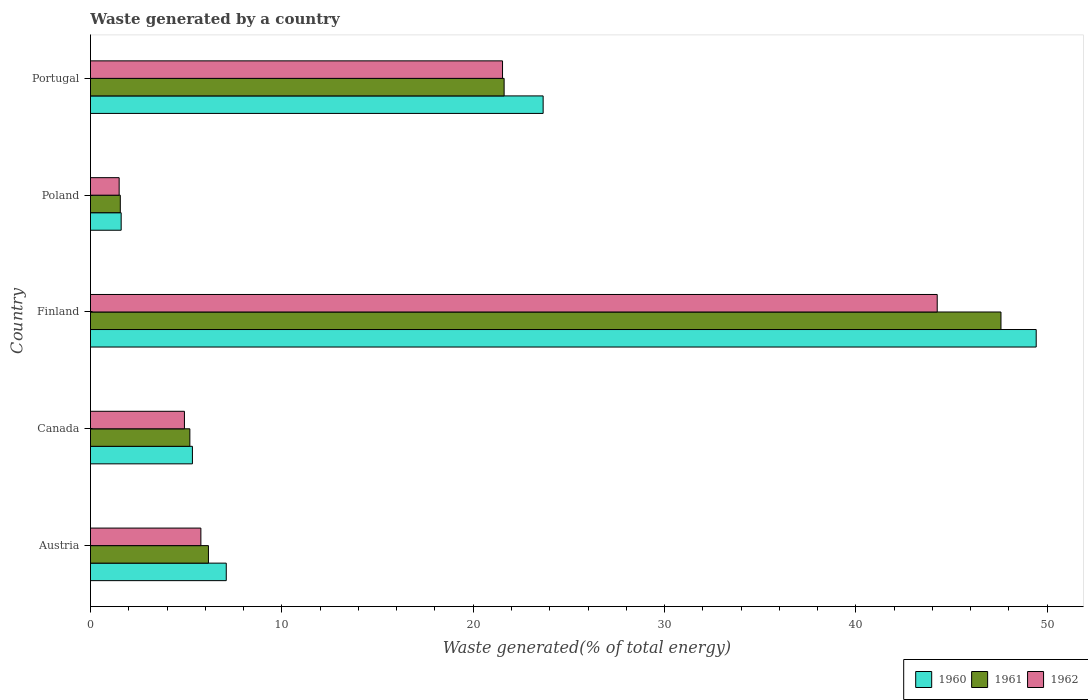How many different coloured bars are there?
Offer a very short reply. 3. How many groups of bars are there?
Give a very brief answer. 5. Are the number of bars per tick equal to the number of legend labels?
Give a very brief answer. Yes. Are the number of bars on each tick of the Y-axis equal?
Give a very brief answer. Yes. How many bars are there on the 3rd tick from the top?
Your response must be concise. 3. How many bars are there on the 5th tick from the bottom?
Provide a succinct answer. 3. What is the label of the 1st group of bars from the top?
Provide a short and direct response. Portugal. What is the total waste generated in 1962 in Poland?
Provide a succinct answer. 1.5. Across all countries, what is the maximum total waste generated in 1962?
Keep it short and to the point. 44.25. Across all countries, what is the minimum total waste generated in 1962?
Keep it short and to the point. 1.5. In which country was the total waste generated in 1960 maximum?
Your answer should be compact. Finland. What is the total total waste generated in 1961 in the graph?
Ensure brevity in your answer.  82.12. What is the difference between the total waste generated in 1962 in Finland and that in Portugal?
Offer a terse response. 22.72. What is the difference between the total waste generated in 1960 in Poland and the total waste generated in 1962 in Canada?
Provide a short and direct response. -3.31. What is the average total waste generated in 1962 per country?
Offer a very short reply. 15.59. What is the difference between the total waste generated in 1962 and total waste generated in 1960 in Portugal?
Provide a succinct answer. -2.12. In how many countries, is the total waste generated in 1962 greater than 22 %?
Provide a succinct answer. 1. What is the ratio of the total waste generated in 1961 in Canada to that in Finland?
Ensure brevity in your answer.  0.11. Is the difference between the total waste generated in 1962 in Canada and Poland greater than the difference between the total waste generated in 1960 in Canada and Poland?
Your answer should be compact. No. What is the difference between the highest and the second highest total waste generated in 1961?
Provide a short and direct response. 25.96. What is the difference between the highest and the lowest total waste generated in 1960?
Your response must be concise. 47.82. What does the 1st bar from the bottom in Poland represents?
Offer a very short reply. 1960. Is it the case that in every country, the sum of the total waste generated in 1960 and total waste generated in 1962 is greater than the total waste generated in 1961?
Your answer should be very brief. Yes. How many bars are there?
Provide a succinct answer. 15. How many countries are there in the graph?
Your answer should be very brief. 5. What is the difference between two consecutive major ticks on the X-axis?
Ensure brevity in your answer.  10. Does the graph contain any zero values?
Ensure brevity in your answer.  No. Where does the legend appear in the graph?
Your answer should be compact. Bottom right. How are the legend labels stacked?
Your response must be concise. Horizontal. What is the title of the graph?
Ensure brevity in your answer.  Waste generated by a country. What is the label or title of the X-axis?
Offer a terse response. Waste generated(% of total energy). What is the label or title of the Y-axis?
Offer a very short reply. Country. What is the Waste generated(% of total energy) in 1960 in Austria?
Your answer should be very brief. 7.1. What is the Waste generated(% of total energy) in 1961 in Austria?
Ensure brevity in your answer.  6.16. What is the Waste generated(% of total energy) in 1962 in Austria?
Your answer should be very brief. 5.77. What is the Waste generated(% of total energy) of 1960 in Canada?
Offer a very short reply. 5.33. What is the Waste generated(% of total energy) in 1961 in Canada?
Your response must be concise. 5.19. What is the Waste generated(% of total energy) of 1962 in Canada?
Provide a succinct answer. 4.91. What is the Waste generated(% of total energy) in 1960 in Finland?
Ensure brevity in your answer.  49.42. What is the Waste generated(% of total energy) in 1961 in Finland?
Offer a terse response. 47.58. What is the Waste generated(% of total energy) of 1962 in Finland?
Provide a short and direct response. 44.25. What is the Waste generated(% of total energy) in 1960 in Poland?
Give a very brief answer. 1.6. What is the Waste generated(% of total energy) in 1961 in Poland?
Your answer should be compact. 1.56. What is the Waste generated(% of total energy) in 1962 in Poland?
Keep it short and to the point. 1.5. What is the Waste generated(% of total energy) of 1960 in Portugal?
Give a very brief answer. 23.66. What is the Waste generated(% of total energy) in 1961 in Portugal?
Keep it short and to the point. 21.62. What is the Waste generated(% of total energy) in 1962 in Portugal?
Ensure brevity in your answer.  21.53. Across all countries, what is the maximum Waste generated(% of total energy) in 1960?
Keep it short and to the point. 49.42. Across all countries, what is the maximum Waste generated(% of total energy) of 1961?
Your answer should be very brief. 47.58. Across all countries, what is the maximum Waste generated(% of total energy) in 1962?
Your answer should be very brief. 44.25. Across all countries, what is the minimum Waste generated(% of total energy) of 1960?
Your answer should be very brief. 1.6. Across all countries, what is the minimum Waste generated(% of total energy) of 1961?
Offer a terse response. 1.56. Across all countries, what is the minimum Waste generated(% of total energy) of 1962?
Keep it short and to the point. 1.5. What is the total Waste generated(% of total energy) in 1960 in the graph?
Offer a very short reply. 87.11. What is the total Waste generated(% of total energy) in 1961 in the graph?
Give a very brief answer. 82.12. What is the total Waste generated(% of total energy) of 1962 in the graph?
Provide a succinct answer. 77.96. What is the difference between the Waste generated(% of total energy) of 1960 in Austria and that in Canada?
Your answer should be very brief. 1.77. What is the difference between the Waste generated(% of total energy) in 1961 in Austria and that in Canada?
Provide a short and direct response. 0.97. What is the difference between the Waste generated(% of total energy) in 1962 in Austria and that in Canada?
Make the answer very short. 0.86. What is the difference between the Waste generated(% of total energy) in 1960 in Austria and that in Finland?
Offer a terse response. -42.33. What is the difference between the Waste generated(% of total energy) in 1961 in Austria and that in Finland?
Offer a very short reply. -41.42. What is the difference between the Waste generated(% of total energy) in 1962 in Austria and that in Finland?
Your answer should be very brief. -38.48. What is the difference between the Waste generated(% of total energy) of 1960 in Austria and that in Poland?
Offer a terse response. 5.49. What is the difference between the Waste generated(% of total energy) in 1961 in Austria and that in Poland?
Provide a short and direct response. 4.61. What is the difference between the Waste generated(% of total energy) of 1962 in Austria and that in Poland?
Keep it short and to the point. 4.27. What is the difference between the Waste generated(% of total energy) of 1960 in Austria and that in Portugal?
Give a very brief answer. -16.56. What is the difference between the Waste generated(% of total energy) in 1961 in Austria and that in Portugal?
Your answer should be compact. -15.45. What is the difference between the Waste generated(% of total energy) in 1962 in Austria and that in Portugal?
Your answer should be compact. -15.76. What is the difference between the Waste generated(% of total energy) in 1960 in Canada and that in Finland?
Make the answer very short. -44.1. What is the difference between the Waste generated(% of total energy) of 1961 in Canada and that in Finland?
Give a very brief answer. -42.39. What is the difference between the Waste generated(% of total energy) of 1962 in Canada and that in Finland?
Give a very brief answer. -39.34. What is the difference between the Waste generated(% of total energy) in 1960 in Canada and that in Poland?
Your answer should be compact. 3.72. What is the difference between the Waste generated(% of total energy) in 1961 in Canada and that in Poland?
Provide a short and direct response. 3.64. What is the difference between the Waste generated(% of total energy) of 1962 in Canada and that in Poland?
Provide a short and direct response. 3.41. What is the difference between the Waste generated(% of total energy) in 1960 in Canada and that in Portugal?
Your response must be concise. -18.33. What is the difference between the Waste generated(% of total energy) in 1961 in Canada and that in Portugal?
Provide a short and direct response. -16.42. What is the difference between the Waste generated(% of total energy) of 1962 in Canada and that in Portugal?
Your response must be concise. -16.62. What is the difference between the Waste generated(% of total energy) of 1960 in Finland and that in Poland?
Offer a very short reply. 47.82. What is the difference between the Waste generated(% of total energy) of 1961 in Finland and that in Poland?
Give a very brief answer. 46.02. What is the difference between the Waste generated(% of total energy) of 1962 in Finland and that in Poland?
Offer a very short reply. 42.75. What is the difference between the Waste generated(% of total energy) in 1960 in Finland and that in Portugal?
Offer a terse response. 25.77. What is the difference between the Waste generated(% of total energy) of 1961 in Finland and that in Portugal?
Provide a succinct answer. 25.96. What is the difference between the Waste generated(% of total energy) of 1962 in Finland and that in Portugal?
Make the answer very short. 22.72. What is the difference between the Waste generated(% of total energy) in 1960 in Poland and that in Portugal?
Keep it short and to the point. -22.05. What is the difference between the Waste generated(% of total energy) of 1961 in Poland and that in Portugal?
Make the answer very short. -20.06. What is the difference between the Waste generated(% of total energy) of 1962 in Poland and that in Portugal?
Offer a very short reply. -20.03. What is the difference between the Waste generated(% of total energy) of 1960 in Austria and the Waste generated(% of total energy) of 1961 in Canada?
Give a very brief answer. 1.9. What is the difference between the Waste generated(% of total energy) in 1960 in Austria and the Waste generated(% of total energy) in 1962 in Canada?
Your response must be concise. 2.19. What is the difference between the Waste generated(% of total energy) of 1961 in Austria and the Waste generated(% of total energy) of 1962 in Canada?
Offer a very short reply. 1.25. What is the difference between the Waste generated(% of total energy) of 1960 in Austria and the Waste generated(% of total energy) of 1961 in Finland?
Ensure brevity in your answer.  -40.48. What is the difference between the Waste generated(% of total energy) of 1960 in Austria and the Waste generated(% of total energy) of 1962 in Finland?
Ensure brevity in your answer.  -37.15. What is the difference between the Waste generated(% of total energy) in 1961 in Austria and the Waste generated(% of total energy) in 1962 in Finland?
Keep it short and to the point. -38.09. What is the difference between the Waste generated(% of total energy) of 1960 in Austria and the Waste generated(% of total energy) of 1961 in Poland?
Make the answer very short. 5.54. What is the difference between the Waste generated(% of total energy) in 1960 in Austria and the Waste generated(% of total energy) in 1962 in Poland?
Keep it short and to the point. 5.6. What is the difference between the Waste generated(% of total energy) in 1961 in Austria and the Waste generated(% of total energy) in 1962 in Poland?
Keep it short and to the point. 4.67. What is the difference between the Waste generated(% of total energy) in 1960 in Austria and the Waste generated(% of total energy) in 1961 in Portugal?
Offer a terse response. -14.52. What is the difference between the Waste generated(% of total energy) of 1960 in Austria and the Waste generated(% of total energy) of 1962 in Portugal?
Your answer should be very brief. -14.44. What is the difference between the Waste generated(% of total energy) in 1961 in Austria and the Waste generated(% of total energy) in 1962 in Portugal?
Provide a succinct answer. -15.37. What is the difference between the Waste generated(% of total energy) of 1960 in Canada and the Waste generated(% of total energy) of 1961 in Finland?
Your answer should be very brief. -42.25. What is the difference between the Waste generated(% of total energy) in 1960 in Canada and the Waste generated(% of total energy) in 1962 in Finland?
Provide a succinct answer. -38.92. What is the difference between the Waste generated(% of total energy) in 1961 in Canada and the Waste generated(% of total energy) in 1962 in Finland?
Offer a terse response. -39.06. What is the difference between the Waste generated(% of total energy) of 1960 in Canada and the Waste generated(% of total energy) of 1961 in Poland?
Your response must be concise. 3.77. What is the difference between the Waste generated(% of total energy) in 1960 in Canada and the Waste generated(% of total energy) in 1962 in Poland?
Make the answer very short. 3.83. What is the difference between the Waste generated(% of total energy) of 1961 in Canada and the Waste generated(% of total energy) of 1962 in Poland?
Keep it short and to the point. 3.7. What is the difference between the Waste generated(% of total energy) in 1960 in Canada and the Waste generated(% of total energy) in 1961 in Portugal?
Give a very brief answer. -16.29. What is the difference between the Waste generated(% of total energy) of 1960 in Canada and the Waste generated(% of total energy) of 1962 in Portugal?
Make the answer very short. -16.21. What is the difference between the Waste generated(% of total energy) in 1961 in Canada and the Waste generated(% of total energy) in 1962 in Portugal?
Ensure brevity in your answer.  -16.34. What is the difference between the Waste generated(% of total energy) in 1960 in Finland and the Waste generated(% of total energy) in 1961 in Poland?
Your response must be concise. 47.86. What is the difference between the Waste generated(% of total energy) in 1960 in Finland and the Waste generated(% of total energy) in 1962 in Poland?
Your answer should be compact. 47.92. What is the difference between the Waste generated(% of total energy) of 1961 in Finland and the Waste generated(% of total energy) of 1962 in Poland?
Make the answer very short. 46.08. What is the difference between the Waste generated(% of total energy) of 1960 in Finland and the Waste generated(% of total energy) of 1961 in Portugal?
Keep it short and to the point. 27.81. What is the difference between the Waste generated(% of total energy) in 1960 in Finland and the Waste generated(% of total energy) in 1962 in Portugal?
Offer a terse response. 27.89. What is the difference between the Waste generated(% of total energy) in 1961 in Finland and the Waste generated(% of total energy) in 1962 in Portugal?
Your response must be concise. 26.05. What is the difference between the Waste generated(% of total energy) in 1960 in Poland and the Waste generated(% of total energy) in 1961 in Portugal?
Your response must be concise. -20.01. What is the difference between the Waste generated(% of total energy) of 1960 in Poland and the Waste generated(% of total energy) of 1962 in Portugal?
Your answer should be compact. -19.93. What is the difference between the Waste generated(% of total energy) of 1961 in Poland and the Waste generated(% of total energy) of 1962 in Portugal?
Make the answer very short. -19.98. What is the average Waste generated(% of total energy) of 1960 per country?
Provide a short and direct response. 17.42. What is the average Waste generated(% of total energy) of 1961 per country?
Your response must be concise. 16.42. What is the average Waste generated(% of total energy) of 1962 per country?
Offer a terse response. 15.59. What is the difference between the Waste generated(% of total energy) in 1960 and Waste generated(% of total energy) in 1961 in Austria?
Keep it short and to the point. 0.93. What is the difference between the Waste generated(% of total energy) of 1960 and Waste generated(% of total energy) of 1962 in Austria?
Provide a short and direct response. 1.33. What is the difference between the Waste generated(% of total energy) of 1961 and Waste generated(% of total energy) of 1962 in Austria?
Give a very brief answer. 0.4. What is the difference between the Waste generated(% of total energy) in 1960 and Waste generated(% of total energy) in 1961 in Canada?
Provide a short and direct response. 0.13. What is the difference between the Waste generated(% of total energy) in 1960 and Waste generated(% of total energy) in 1962 in Canada?
Your response must be concise. 0.42. What is the difference between the Waste generated(% of total energy) in 1961 and Waste generated(% of total energy) in 1962 in Canada?
Make the answer very short. 0.28. What is the difference between the Waste generated(% of total energy) in 1960 and Waste generated(% of total energy) in 1961 in Finland?
Your answer should be compact. 1.84. What is the difference between the Waste generated(% of total energy) in 1960 and Waste generated(% of total energy) in 1962 in Finland?
Give a very brief answer. 5.17. What is the difference between the Waste generated(% of total energy) of 1961 and Waste generated(% of total energy) of 1962 in Finland?
Your response must be concise. 3.33. What is the difference between the Waste generated(% of total energy) in 1960 and Waste generated(% of total energy) in 1961 in Poland?
Offer a very short reply. 0.05. What is the difference between the Waste generated(% of total energy) of 1960 and Waste generated(% of total energy) of 1962 in Poland?
Provide a succinct answer. 0.11. What is the difference between the Waste generated(% of total energy) of 1961 and Waste generated(% of total energy) of 1962 in Poland?
Your response must be concise. 0.06. What is the difference between the Waste generated(% of total energy) of 1960 and Waste generated(% of total energy) of 1961 in Portugal?
Provide a succinct answer. 2.04. What is the difference between the Waste generated(% of total energy) in 1960 and Waste generated(% of total energy) in 1962 in Portugal?
Keep it short and to the point. 2.12. What is the difference between the Waste generated(% of total energy) in 1961 and Waste generated(% of total energy) in 1962 in Portugal?
Make the answer very short. 0.08. What is the ratio of the Waste generated(% of total energy) of 1960 in Austria to that in Canada?
Your answer should be very brief. 1.33. What is the ratio of the Waste generated(% of total energy) in 1961 in Austria to that in Canada?
Provide a short and direct response. 1.19. What is the ratio of the Waste generated(% of total energy) of 1962 in Austria to that in Canada?
Give a very brief answer. 1.17. What is the ratio of the Waste generated(% of total energy) in 1960 in Austria to that in Finland?
Give a very brief answer. 0.14. What is the ratio of the Waste generated(% of total energy) in 1961 in Austria to that in Finland?
Provide a short and direct response. 0.13. What is the ratio of the Waste generated(% of total energy) of 1962 in Austria to that in Finland?
Give a very brief answer. 0.13. What is the ratio of the Waste generated(% of total energy) in 1960 in Austria to that in Poland?
Your answer should be very brief. 4.42. What is the ratio of the Waste generated(% of total energy) of 1961 in Austria to that in Poland?
Provide a short and direct response. 3.96. What is the ratio of the Waste generated(% of total energy) in 1962 in Austria to that in Poland?
Your response must be concise. 3.85. What is the ratio of the Waste generated(% of total energy) in 1960 in Austria to that in Portugal?
Your answer should be compact. 0.3. What is the ratio of the Waste generated(% of total energy) in 1961 in Austria to that in Portugal?
Your answer should be compact. 0.29. What is the ratio of the Waste generated(% of total energy) of 1962 in Austria to that in Portugal?
Keep it short and to the point. 0.27. What is the ratio of the Waste generated(% of total energy) of 1960 in Canada to that in Finland?
Ensure brevity in your answer.  0.11. What is the ratio of the Waste generated(% of total energy) in 1961 in Canada to that in Finland?
Ensure brevity in your answer.  0.11. What is the ratio of the Waste generated(% of total energy) of 1962 in Canada to that in Finland?
Offer a terse response. 0.11. What is the ratio of the Waste generated(% of total energy) of 1960 in Canada to that in Poland?
Ensure brevity in your answer.  3.32. What is the ratio of the Waste generated(% of total energy) of 1961 in Canada to that in Poland?
Provide a succinct answer. 3.33. What is the ratio of the Waste generated(% of total energy) of 1962 in Canada to that in Poland?
Provide a short and direct response. 3.28. What is the ratio of the Waste generated(% of total energy) of 1960 in Canada to that in Portugal?
Your response must be concise. 0.23. What is the ratio of the Waste generated(% of total energy) in 1961 in Canada to that in Portugal?
Ensure brevity in your answer.  0.24. What is the ratio of the Waste generated(% of total energy) in 1962 in Canada to that in Portugal?
Your answer should be very brief. 0.23. What is the ratio of the Waste generated(% of total energy) in 1960 in Finland to that in Poland?
Provide a succinct answer. 30.8. What is the ratio of the Waste generated(% of total energy) in 1961 in Finland to that in Poland?
Your answer should be very brief. 30.53. What is the ratio of the Waste generated(% of total energy) in 1962 in Finland to that in Poland?
Your answer should be very brief. 29.52. What is the ratio of the Waste generated(% of total energy) in 1960 in Finland to that in Portugal?
Your answer should be compact. 2.09. What is the ratio of the Waste generated(% of total energy) of 1961 in Finland to that in Portugal?
Offer a terse response. 2.2. What is the ratio of the Waste generated(% of total energy) in 1962 in Finland to that in Portugal?
Your answer should be compact. 2.05. What is the ratio of the Waste generated(% of total energy) in 1960 in Poland to that in Portugal?
Keep it short and to the point. 0.07. What is the ratio of the Waste generated(% of total energy) in 1961 in Poland to that in Portugal?
Your response must be concise. 0.07. What is the ratio of the Waste generated(% of total energy) of 1962 in Poland to that in Portugal?
Your answer should be very brief. 0.07. What is the difference between the highest and the second highest Waste generated(% of total energy) of 1960?
Keep it short and to the point. 25.77. What is the difference between the highest and the second highest Waste generated(% of total energy) of 1961?
Your answer should be very brief. 25.96. What is the difference between the highest and the second highest Waste generated(% of total energy) in 1962?
Your answer should be compact. 22.72. What is the difference between the highest and the lowest Waste generated(% of total energy) of 1960?
Your answer should be very brief. 47.82. What is the difference between the highest and the lowest Waste generated(% of total energy) of 1961?
Offer a very short reply. 46.02. What is the difference between the highest and the lowest Waste generated(% of total energy) in 1962?
Offer a very short reply. 42.75. 